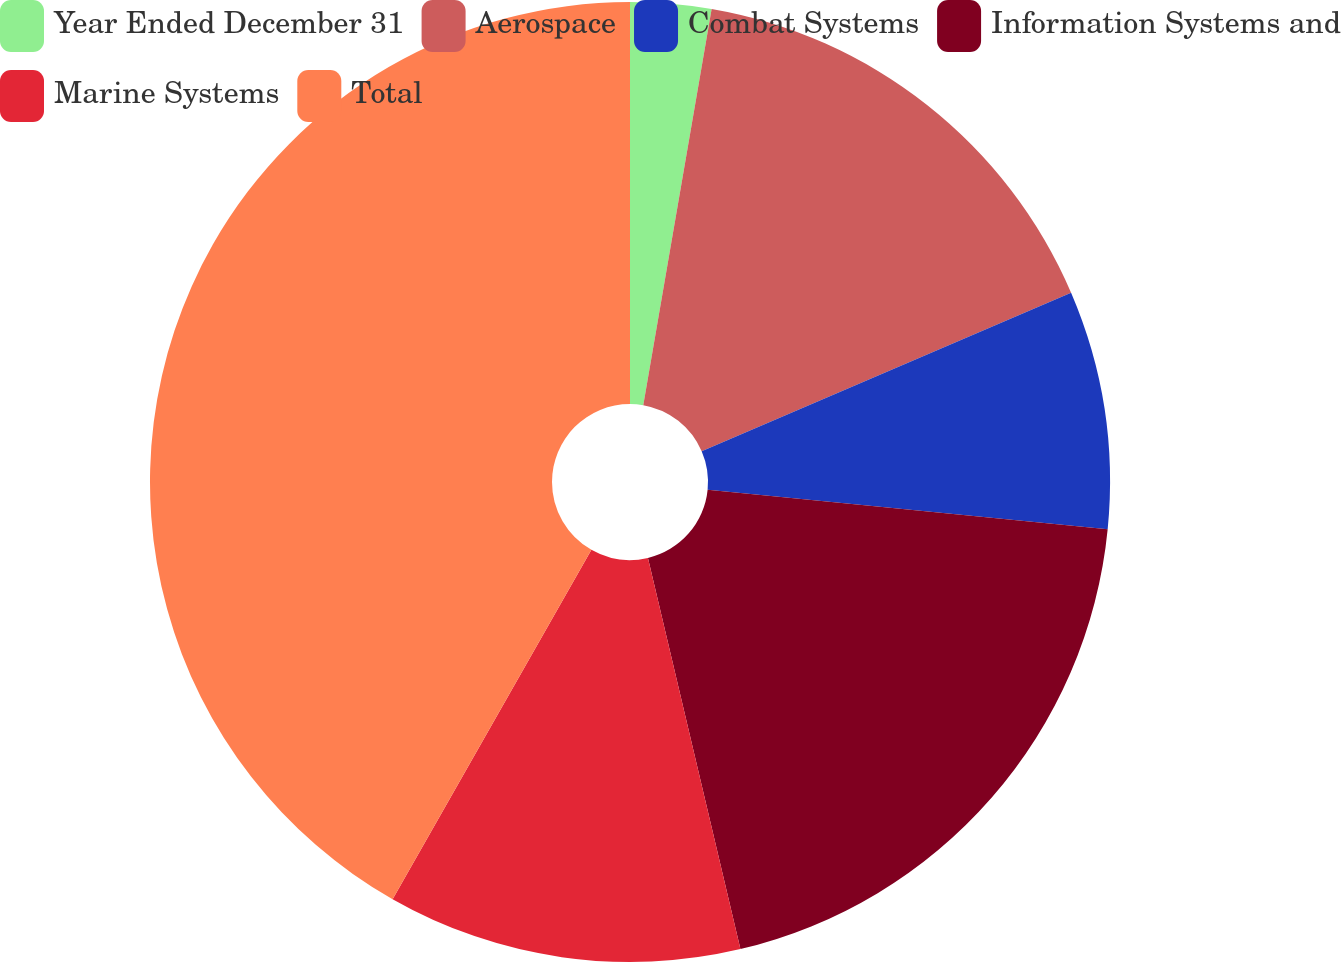<chart> <loc_0><loc_0><loc_500><loc_500><pie_chart><fcel>Year Ended December 31<fcel>Aerospace<fcel>Combat Systems<fcel>Information Systems and<fcel>Marine Systems<fcel>Total<nl><fcel>2.72%<fcel>15.83%<fcel>8.02%<fcel>19.74%<fcel>11.93%<fcel>41.77%<nl></chart> 